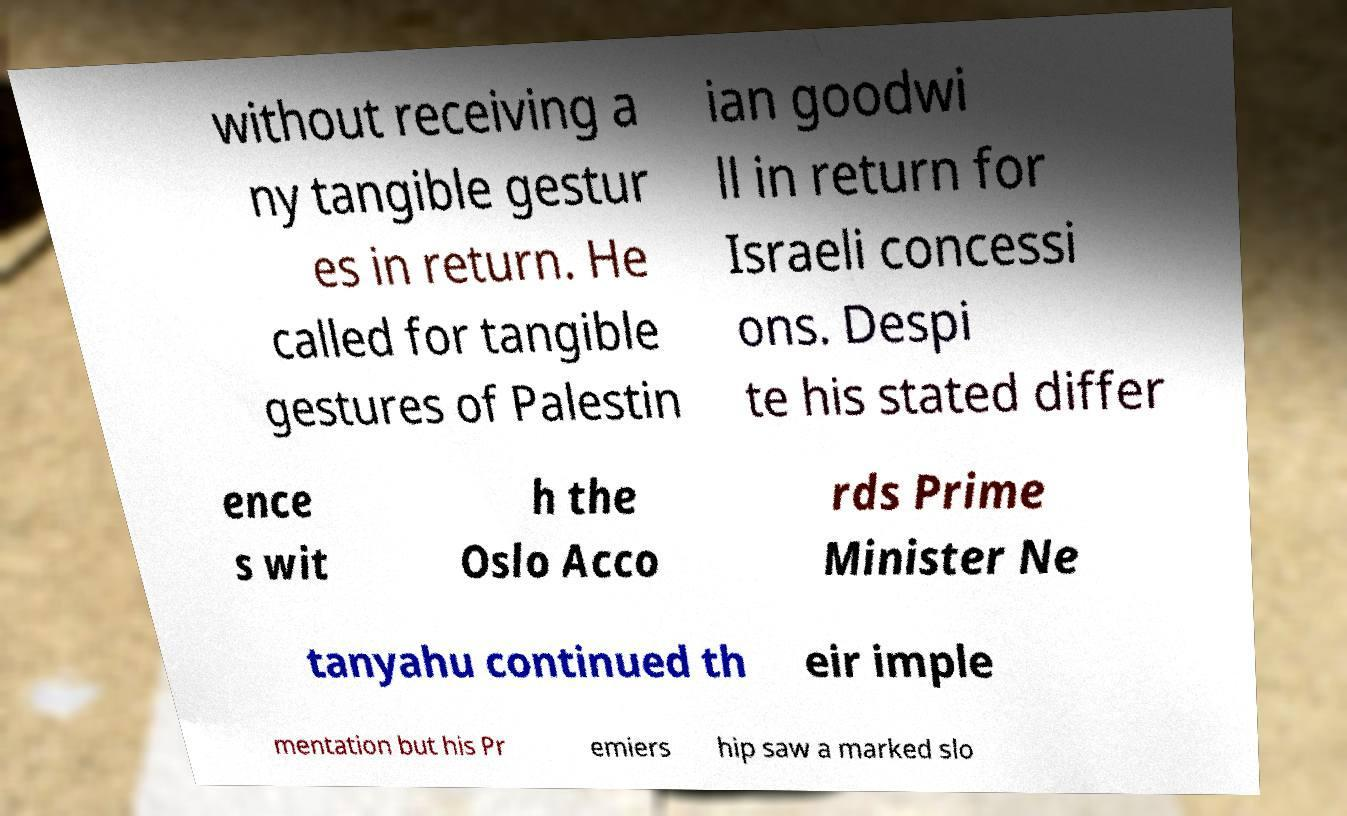For documentation purposes, I need the text within this image transcribed. Could you provide that? without receiving a ny tangible gestur es in return. He called for tangible gestures of Palestin ian goodwi ll in return for Israeli concessi ons. Despi te his stated differ ence s wit h the Oslo Acco rds Prime Minister Ne tanyahu continued th eir imple mentation but his Pr emiers hip saw a marked slo 